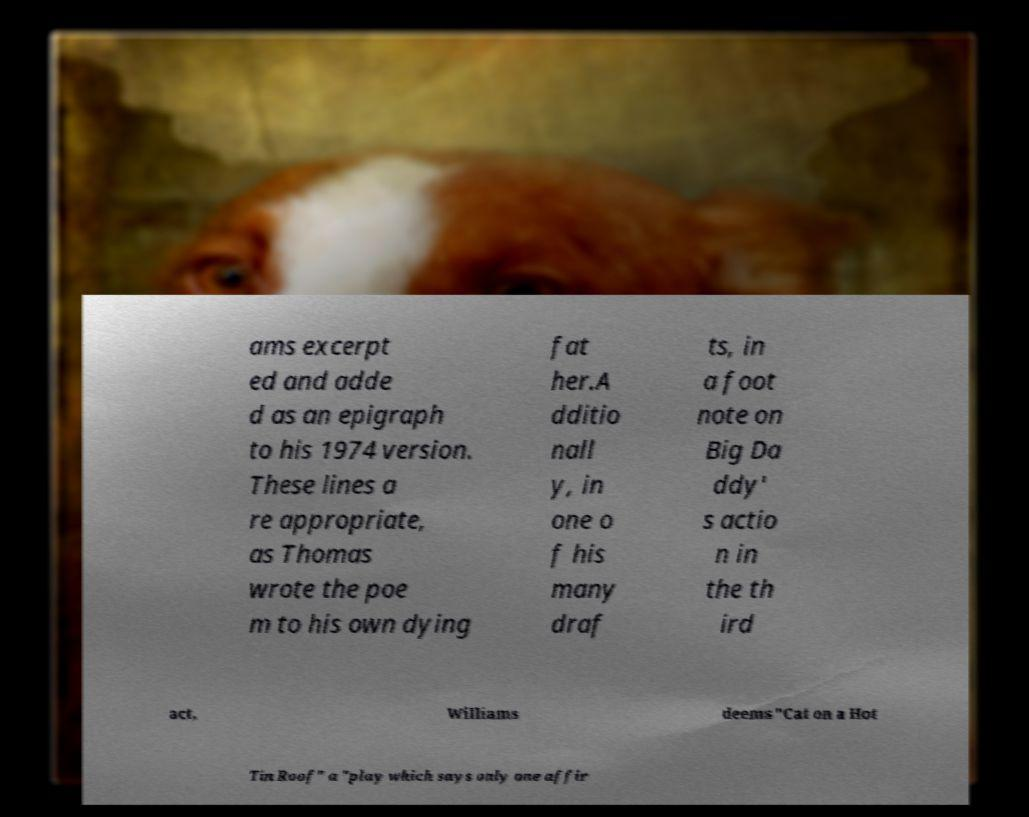Could you extract and type out the text from this image? ams excerpt ed and adde d as an epigraph to his 1974 version. These lines a re appropriate, as Thomas wrote the poe m to his own dying fat her.A dditio nall y, in one o f his many draf ts, in a foot note on Big Da ddy' s actio n in the th ird act, Williams deems "Cat on a Hot Tin Roof" a "play which says only one affir 